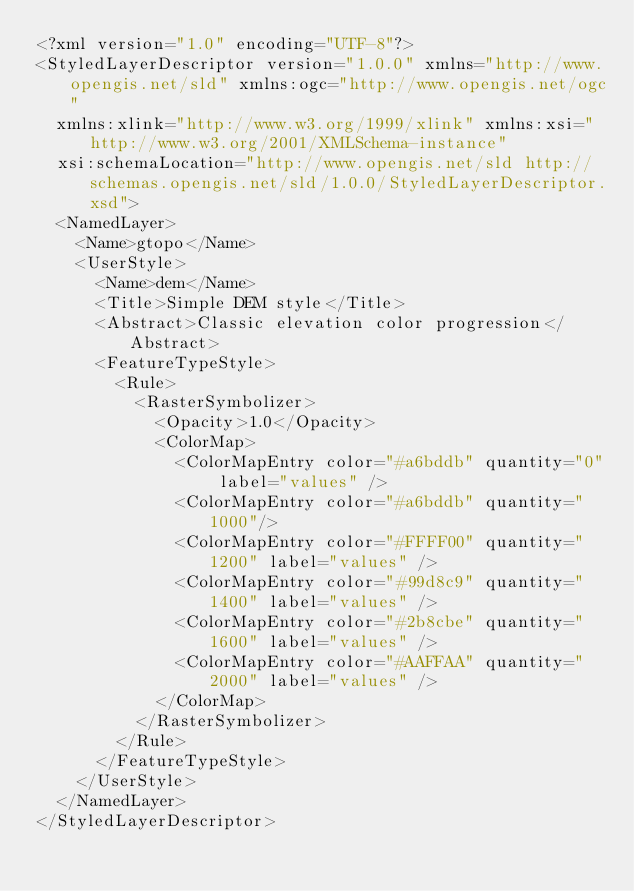Convert code to text. <code><loc_0><loc_0><loc_500><loc_500><_Scheme_><?xml version="1.0" encoding="UTF-8"?>
<StyledLayerDescriptor version="1.0.0" xmlns="http://www.opengis.net/sld" xmlns:ogc="http://www.opengis.net/ogc"
  xmlns:xlink="http://www.w3.org/1999/xlink" xmlns:xsi="http://www.w3.org/2001/XMLSchema-instance"
  xsi:schemaLocation="http://www.opengis.net/sld http://schemas.opengis.net/sld/1.0.0/StyledLayerDescriptor.xsd">
  <NamedLayer>
    <Name>gtopo</Name>
    <UserStyle>
      <Name>dem</Name>
      <Title>Simple DEM style</Title>
      <Abstract>Classic elevation color progression</Abstract>
      <FeatureTypeStyle>
        <Rule>
          <RasterSymbolizer>
            <Opacity>1.0</Opacity>
            <ColorMap>
              <ColorMapEntry color="#a6bddb" quantity="0" label="values" />
              <ColorMapEntry color="#a6bddb" quantity="1000"/>
              <ColorMapEntry color="#FFFF00" quantity="1200" label="values" />
              <ColorMapEntry color="#99d8c9" quantity="1400" label="values" />
              <ColorMapEntry color="#2b8cbe" quantity="1600" label="values" />
              <ColorMapEntry color="#AAFFAA" quantity="2000" label="values" />
            </ColorMap>
          </RasterSymbolizer>
        </Rule>
      </FeatureTypeStyle>
    </UserStyle>
  </NamedLayer>
</StyledLayerDescriptor>
</code> 